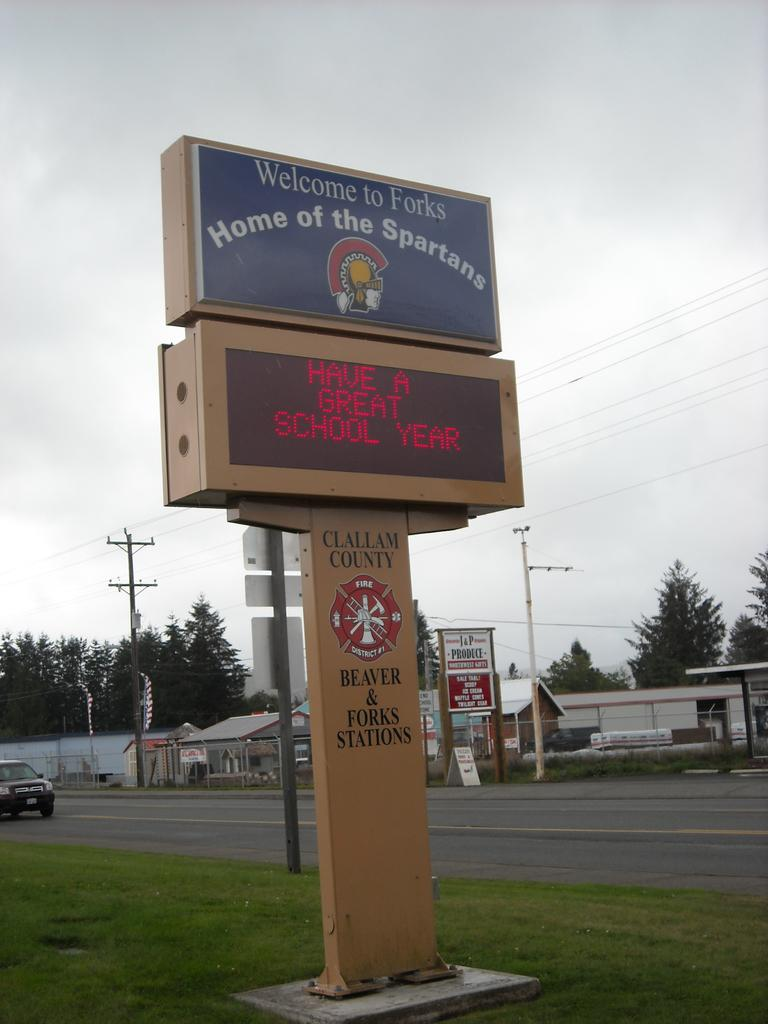<image>
Present a compact description of the photo's key features. a school sign for the town of forks, home of the spartans 